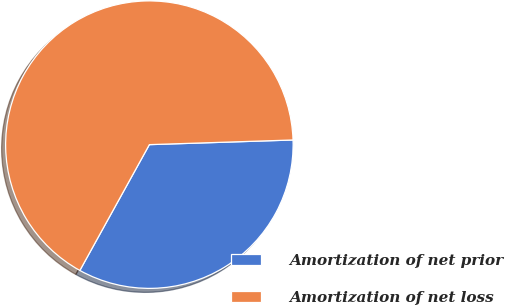<chart> <loc_0><loc_0><loc_500><loc_500><pie_chart><fcel>Amortization of net prior<fcel>Amortization of net loss<nl><fcel>33.55%<fcel>66.45%<nl></chart> 